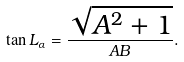<formula> <loc_0><loc_0><loc_500><loc_500>\tan { L _ { \alpha } } = \frac { \sqrt { A ^ { 2 } + 1 } } { A B } .</formula> 